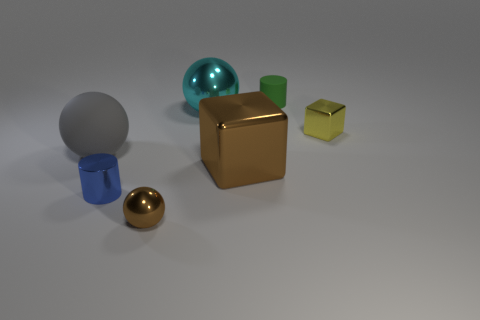Subtract all shiny spheres. How many spheres are left? 1 Subtract all yellow blocks. How many blocks are left? 1 Subtract all blocks. How many objects are left? 5 Subtract 2 balls. How many balls are left? 1 Add 1 big purple balls. How many objects exist? 8 Add 4 big green rubber spheres. How many big green rubber spheres exist? 4 Subtract 0 green blocks. How many objects are left? 7 Subtract all gray cylinders. Subtract all gray blocks. How many cylinders are left? 2 Subtract all green cubes. How many cyan cylinders are left? 0 Subtract all brown objects. Subtract all tiny blue things. How many objects are left? 4 